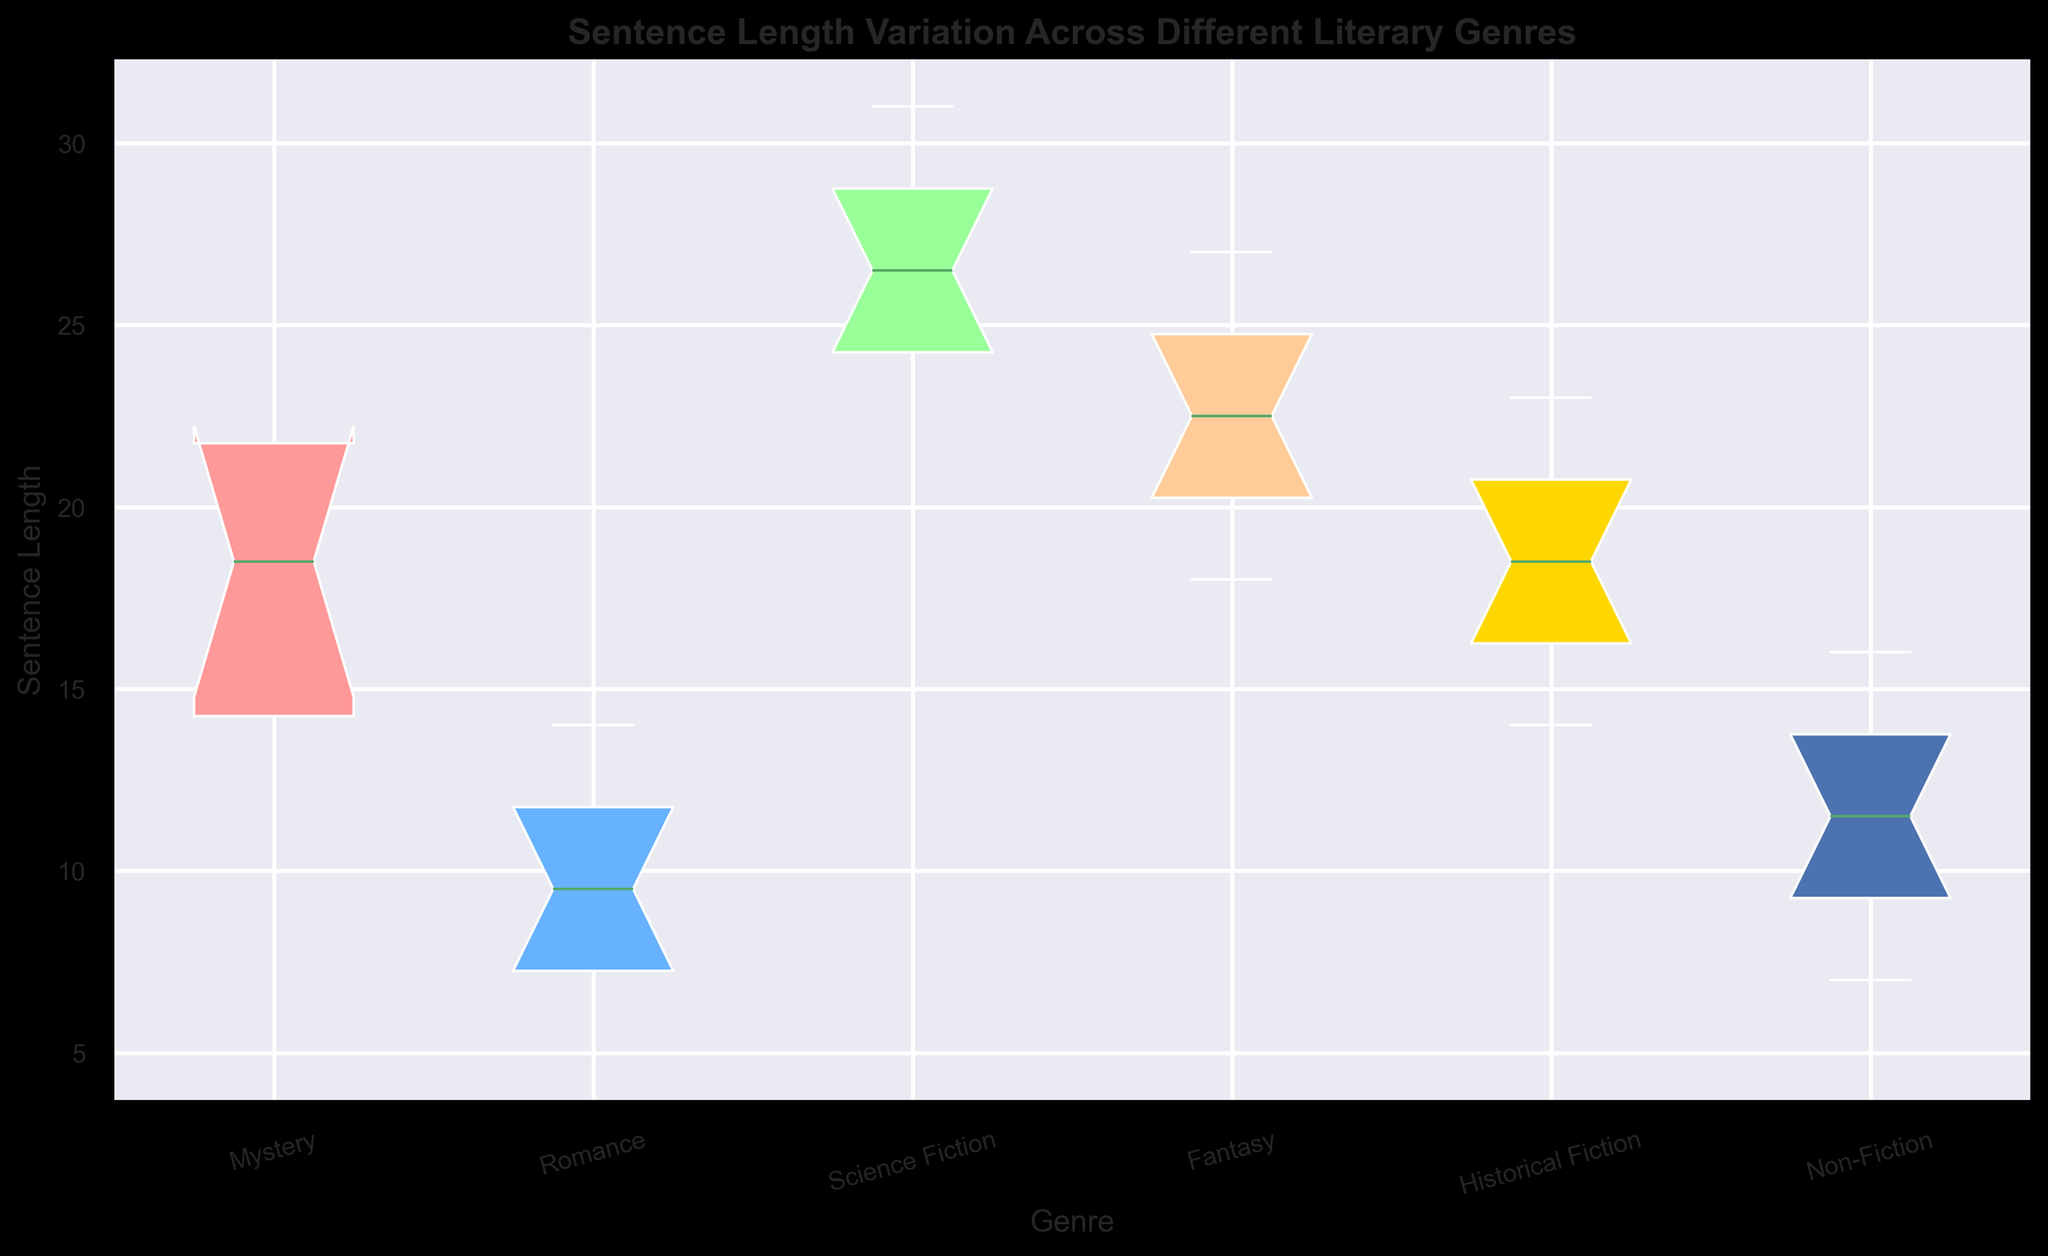What is the median sentence length for the genre "Mystery"? The median is the middle value when the sentence lengths are ordered. For "Mystery," the ordered sentence lengths are 10, 12, 14, 15, 17, 20, 21, 22, 25, 30. The middle value in this ordered list (for an even number of data points) is the average of the 5th (17) and 6th (20) values. So, the median is (17 + 20)/2 = 18.5.
Answer: 18.5 Which genre has the highest median sentence length? By looking at the middle line (median) of each box plot, we can see that "Science Fiction" has the highest median sentence length.
Answer: Science Fiction Which genre exhibits the widest range of sentence lengths? The range is determined by the distance between the lowest and highest values (whiskers). "Mystery" appears to have the widest range since the whiskers extend from the lowest value of 10 to the highest value of 30.
Answer: Mystery How does the interquartile range (IQR) of "Romance" compare to that of "Non-Fiction"? The IQR is the range between the first quartile (Q1) and the third quartile (Q3), represented by the length of the box in the box plot. For "Romance," the box length is shorter than that of "Non-Fiction," indicating a smaller IQR for "Romance."
Answer: Non-Fiction has a larger IQR than Romance Is the distribution of sentence lengths in "Fantasy" skewed, and if so, in which direction? Skewness is indicated by the relative position of the median within the box and the size of the whiskers. For "Fantasy," the median is closer to the left edge of the box, and the right whisker is longer. This indicates a right (positive) skew.
Answer: Right (positive) Which genre has the smallest interquartile range (IQR)? By examining the length of the boxes in each genre, "Historical Fiction" has the smallest IQR since the box is the shortest among all the genres.
Answer: Historical Fiction Do any of the genres contain outliers, and if so, which ones? Outliers are typically represented by individual points that lie outside the whiskers. "Mystery" has an apparent outlier, where a single point is above the upper whisker.
Answer: Mystery Is the median sentence length for "Romance" greater than the first quartile (Q1) of "Fantasy"? The median sentence length for "Romance" is represented by the middle line in the "Romance" box plot. The first quartile (Q1) for "Fantasy" is the lower edge of the "Fantasy" box plot. The median for "Romance" is around 10.5, and Q1 for "Fantasy" is around 20. Therefore, the median for "Romance" is not greater than Q1 for "Fantasy."
Answer: No What is the interquartile range (IQR) for "Science Fiction"? The IQR is the range between the first quartile (Q1) and the third quartile (Q3). For "Science Fiction," Q1 is around 24 and Q3 is around 28, making the IQR 28 - 24 = 4.
Answer: 4 